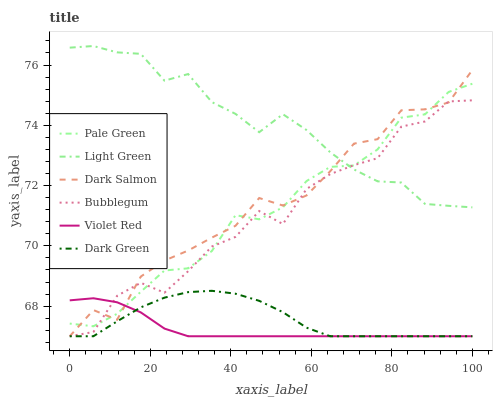Does Violet Red have the minimum area under the curve?
Answer yes or no. Yes. Does Light Green have the maximum area under the curve?
Answer yes or no. Yes. Does Dark Salmon have the minimum area under the curve?
Answer yes or no. No. Does Dark Salmon have the maximum area under the curve?
Answer yes or no. No. Is Violet Red the smoothest?
Answer yes or no. Yes. Is Bubblegum the roughest?
Answer yes or no. Yes. Is Dark Salmon the smoothest?
Answer yes or no. No. Is Dark Salmon the roughest?
Answer yes or no. No. Does Violet Red have the lowest value?
Answer yes or no. Yes. Does Pale Green have the lowest value?
Answer yes or no. No. Does Light Green have the highest value?
Answer yes or no. Yes. Does Dark Salmon have the highest value?
Answer yes or no. No. Is Dark Green less than Pale Green?
Answer yes or no. Yes. Is Light Green greater than Violet Red?
Answer yes or no. Yes. Does Dark Salmon intersect Pale Green?
Answer yes or no. Yes. Is Dark Salmon less than Pale Green?
Answer yes or no. No. Is Dark Salmon greater than Pale Green?
Answer yes or no. No. Does Dark Green intersect Pale Green?
Answer yes or no. No. 